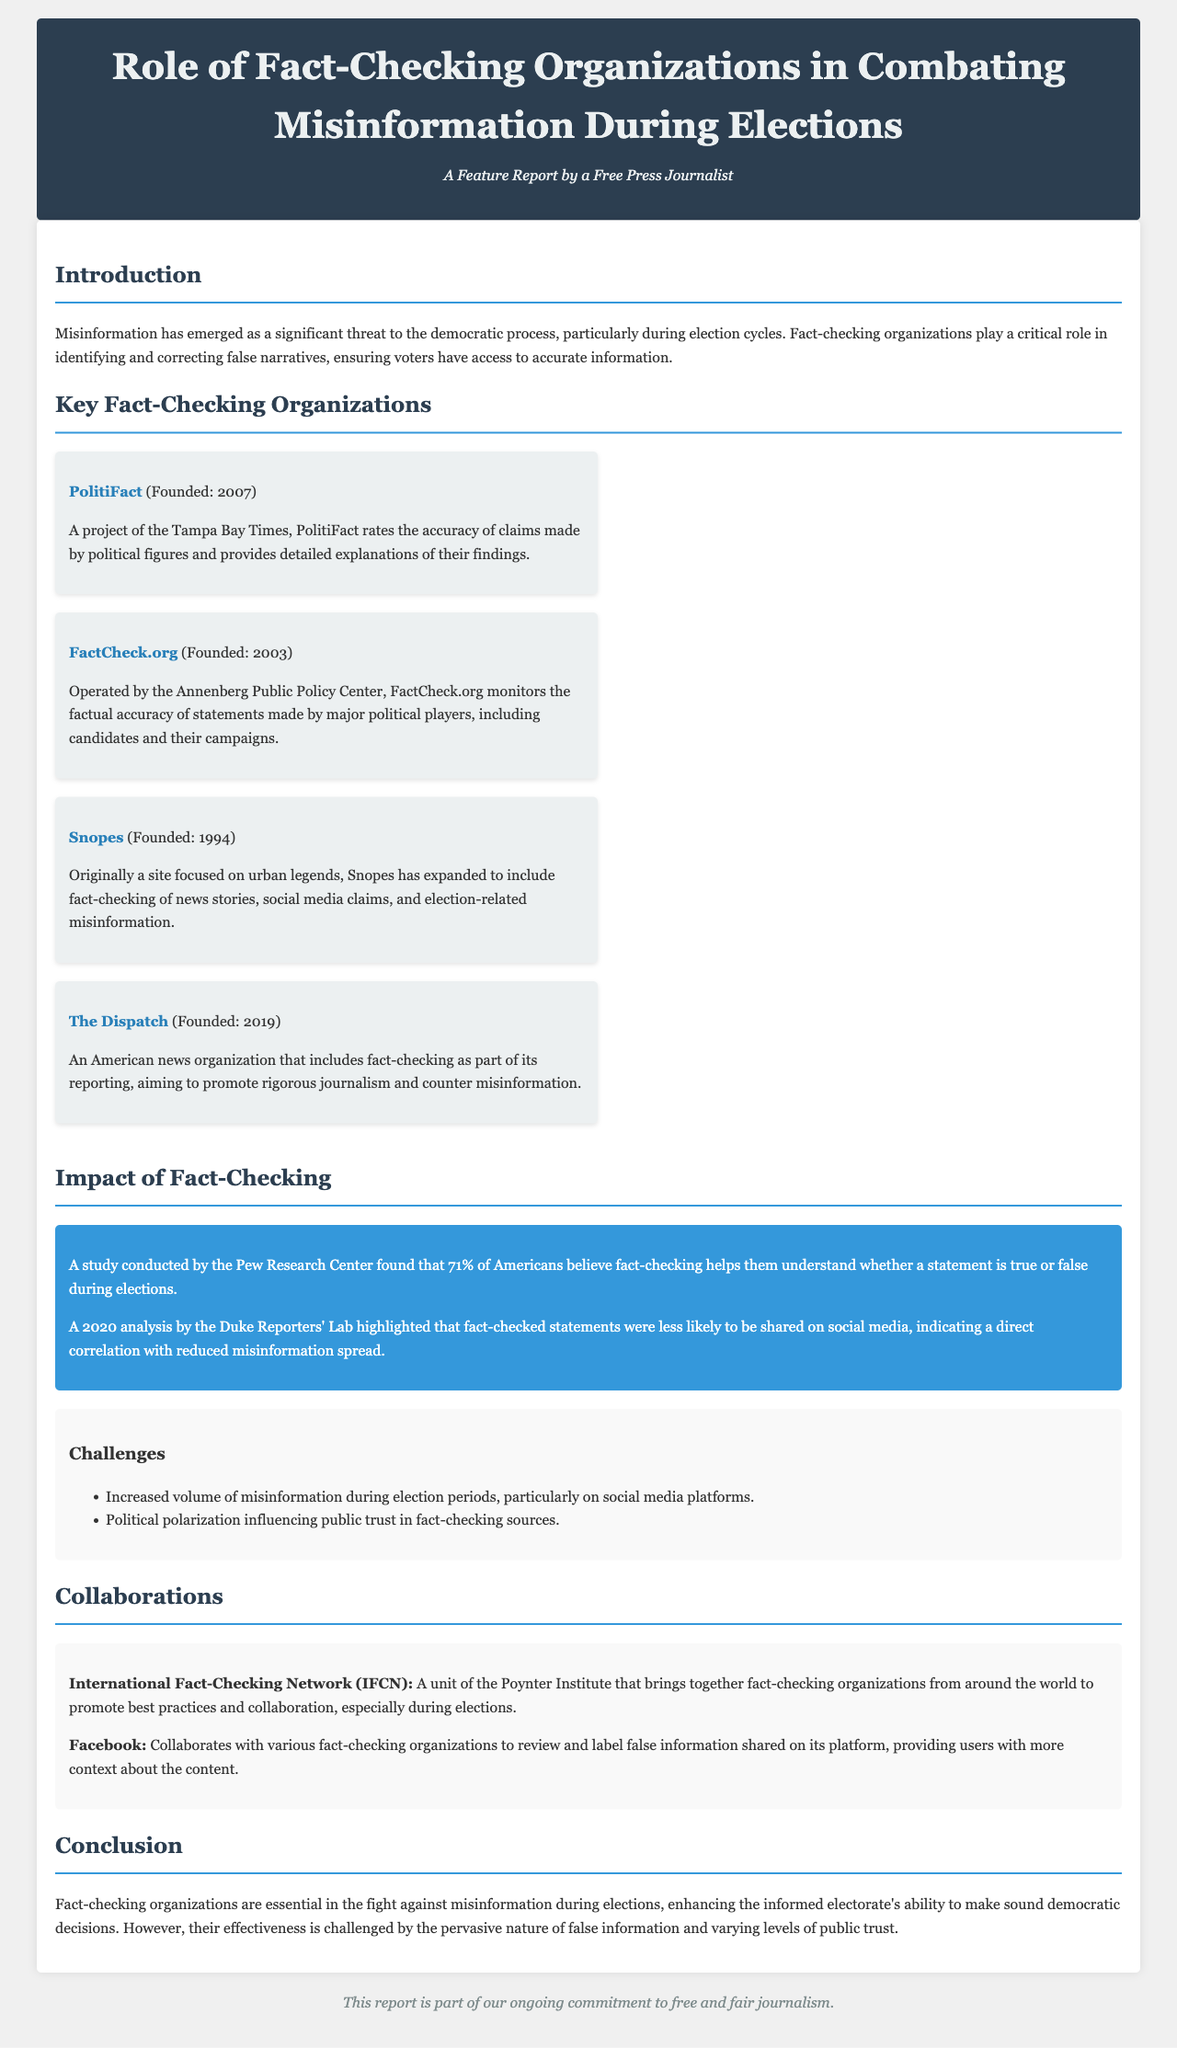What is the title of the report? The title of the report is displayed prominently at the top of the document.
Answer: Role of Fact-Checking Organizations in Combating Misinformation During Elections Which organization was founded in 2003? The organization founded in 2003 is specified in the section detailing key fact-checking organizations.
Answer: FactCheck.org What percentage of Americans believe fact-checking helps them understand statements during elections? This percentage is found in the impact statistics section.
Answer: 71% What is a challenge faced by fact-checking organizations? The document lists several challenges faced by fact-checking organizations.
Answer: Increased volume of misinformation Who collaborates with fact-checking organizations on Facebook? The document specifies the collaboration involving Facebook and fact-checking organizations.
Answer: Various fact-checking organizations What is the IFCN? The IFCN is described in the collaborations section of the report.
Answer: International Fact-Checking Network What year was Snopes founded? The founding year of Snopes is included in the key organizations section.
Answer: 1994 What type of report is this document part of? The document specifies its type in the footer.
Answer: Feature Report 